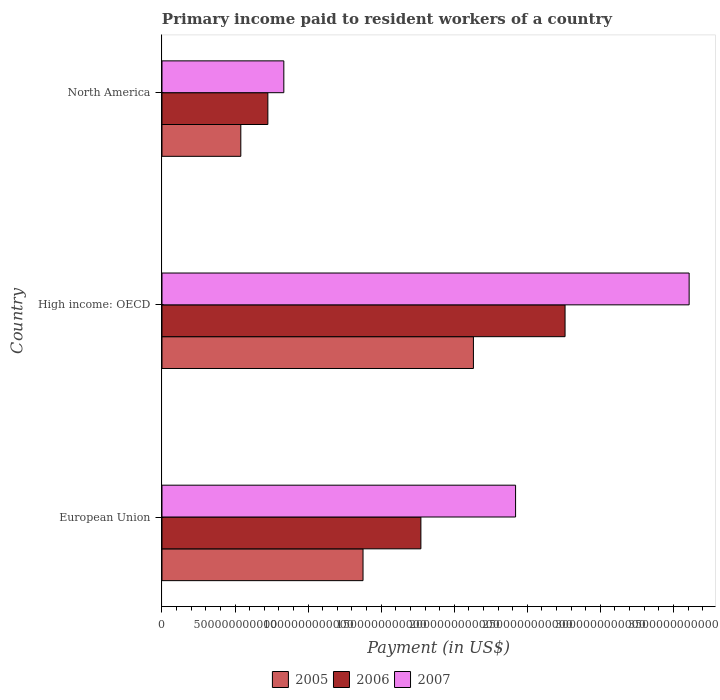How many different coloured bars are there?
Ensure brevity in your answer.  3. How many groups of bars are there?
Provide a succinct answer. 3. How many bars are there on the 3rd tick from the bottom?
Provide a short and direct response. 3. What is the label of the 2nd group of bars from the top?
Keep it short and to the point. High income: OECD. In how many cases, is the number of bars for a given country not equal to the number of legend labels?
Keep it short and to the point. 0. What is the amount paid to workers in 2006 in North America?
Make the answer very short. 7.24e+11. Across all countries, what is the maximum amount paid to workers in 2005?
Offer a very short reply. 2.13e+12. Across all countries, what is the minimum amount paid to workers in 2005?
Offer a very short reply. 5.39e+11. In which country was the amount paid to workers in 2005 maximum?
Your answer should be very brief. High income: OECD. What is the total amount paid to workers in 2007 in the graph?
Provide a succinct answer. 6.86e+12. What is the difference between the amount paid to workers in 2007 in European Union and that in North America?
Ensure brevity in your answer.  1.59e+12. What is the difference between the amount paid to workers in 2007 in High income: OECD and the amount paid to workers in 2006 in European Union?
Give a very brief answer. 1.84e+12. What is the average amount paid to workers in 2006 per country?
Your answer should be very brief. 1.75e+12. What is the difference between the amount paid to workers in 2006 and amount paid to workers in 2007 in High income: OECD?
Offer a very short reply. -8.49e+11. What is the ratio of the amount paid to workers in 2005 in European Union to that in High income: OECD?
Ensure brevity in your answer.  0.65. Is the difference between the amount paid to workers in 2006 in European Union and North America greater than the difference between the amount paid to workers in 2007 in European Union and North America?
Offer a terse response. No. What is the difference between the highest and the second highest amount paid to workers in 2006?
Offer a very short reply. 9.87e+11. What is the difference between the highest and the lowest amount paid to workers in 2006?
Your answer should be very brief. 2.03e+12. In how many countries, is the amount paid to workers in 2006 greater than the average amount paid to workers in 2006 taken over all countries?
Offer a terse response. 2. Is it the case that in every country, the sum of the amount paid to workers in 2007 and amount paid to workers in 2005 is greater than the amount paid to workers in 2006?
Your answer should be very brief. Yes. How many bars are there?
Give a very brief answer. 9. Are all the bars in the graph horizontal?
Your response must be concise. Yes. How many countries are there in the graph?
Give a very brief answer. 3. What is the difference between two consecutive major ticks on the X-axis?
Keep it short and to the point. 5.00e+11. How are the legend labels stacked?
Your response must be concise. Horizontal. What is the title of the graph?
Make the answer very short. Primary income paid to resident workers of a country. Does "1995" appear as one of the legend labels in the graph?
Offer a very short reply. No. What is the label or title of the X-axis?
Give a very brief answer. Payment (in US$). What is the Payment (in US$) in 2005 in European Union?
Your answer should be compact. 1.38e+12. What is the Payment (in US$) in 2006 in European Union?
Provide a succinct answer. 1.77e+12. What is the Payment (in US$) of 2007 in European Union?
Make the answer very short. 2.42e+12. What is the Payment (in US$) of 2005 in High income: OECD?
Give a very brief answer. 2.13e+12. What is the Payment (in US$) of 2006 in High income: OECD?
Keep it short and to the point. 2.76e+12. What is the Payment (in US$) in 2007 in High income: OECD?
Offer a very short reply. 3.61e+12. What is the Payment (in US$) of 2005 in North America?
Your answer should be very brief. 5.39e+11. What is the Payment (in US$) of 2006 in North America?
Give a very brief answer. 7.24e+11. What is the Payment (in US$) in 2007 in North America?
Ensure brevity in your answer.  8.34e+11. Across all countries, what is the maximum Payment (in US$) in 2005?
Your response must be concise. 2.13e+12. Across all countries, what is the maximum Payment (in US$) in 2006?
Make the answer very short. 2.76e+12. Across all countries, what is the maximum Payment (in US$) in 2007?
Your answer should be very brief. 3.61e+12. Across all countries, what is the minimum Payment (in US$) of 2005?
Offer a terse response. 5.39e+11. Across all countries, what is the minimum Payment (in US$) of 2006?
Make the answer very short. 7.24e+11. Across all countries, what is the minimum Payment (in US$) of 2007?
Your answer should be compact. 8.34e+11. What is the total Payment (in US$) in 2005 in the graph?
Offer a terse response. 4.05e+12. What is the total Payment (in US$) of 2006 in the graph?
Ensure brevity in your answer.  5.25e+12. What is the total Payment (in US$) in 2007 in the graph?
Ensure brevity in your answer.  6.86e+12. What is the difference between the Payment (in US$) of 2005 in European Union and that in High income: OECD?
Give a very brief answer. -7.55e+11. What is the difference between the Payment (in US$) of 2006 in European Union and that in High income: OECD?
Keep it short and to the point. -9.87e+11. What is the difference between the Payment (in US$) in 2007 in European Union and that in High income: OECD?
Give a very brief answer. -1.19e+12. What is the difference between the Payment (in US$) of 2005 in European Union and that in North America?
Provide a succinct answer. 8.36e+11. What is the difference between the Payment (in US$) in 2006 in European Union and that in North America?
Provide a succinct answer. 1.05e+12. What is the difference between the Payment (in US$) in 2007 in European Union and that in North America?
Offer a very short reply. 1.59e+12. What is the difference between the Payment (in US$) in 2005 in High income: OECD and that in North America?
Your answer should be compact. 1.59e+12. What is the difference between the Payment (in US$) of 2006 in High income: OECD and that in North America?
Give a very brief answer. 2.03e+12. What is the difference between the Payment (in US$) in 2007 in High income: OECD and that in North America?
Your answer should be compact. 2.77e+12. What is the difference between the Payment (in US$) in 2005 in European Union and the Payment (in US$) in 2006 in High income: OECD?
Keep it short and to the point. -1.38e+12. What is the difference between the Payment (in US$) of 2005 in European Union and the Payment (in US$) of 2007 in High income: OECD?
Your response must be concise. -2.23e+12. What is the difference between the Payment (in US$) in 2006 in European Union and the Payment (in US$) in 2007 in High income: OECD?
Give a very brief answer. -1.84e+12. What is the difference between the Payment (in US$) in 2005 in European Union and the Payment (in US$) in 2006 in North America?
Keep it short and to the point. 6.51e+11. What is the difference between the Payment (in US$) in 2005 in European Union and the Payment (in US$) in 2007 in North America?
Give a very brief answer. 5.42e+11. What is the difference between the Payment (in US$) in 2006 in European Union and the Payment (in US$) in 2007 in North America?
Give a very brief answer. 9.38e+11. What is the difference between the Payment (in US$) in 2005 in High income: OECD and the Payment (in US$) in 2006 in North America?
Your answer should be very brief. 1.41e+12. What is the difference between the Payment (in US$) of 2005 in High income: OECD and the Payment (in US$) of 2007 in North America?
Your answer should be very brief. 1.30e+12. What is the difference between the Payment (in US$) in 2006 in High income: OECD and the Payment (in US$) in 2007 in North America?
Offer a terse response. 1.92e+12. What is the average Payment (in US$) in 2005 per country?
Make the answer very short. 1.35e+12. What is the average Payment (in US$) of 2006 per country?
Your answer should be very brief. 1.75e+12. What is the average Payment (in US$) in 2007 per country?
Provide a succinct answer. 2.29e+12. What is the difference between the Payment (in US$) in 2005 and Payment (in US$) in 2006 in European Union?
Provide a succinct answer. -3.96e+11. What is the difference between the Payment (in US$) in 2005 and Payment (in US$) in 2007 in European Union?
Your answer should be very brief. -1.04e+12. What is the difference between the Payment (in US$) of 2006 and Payment (in US$) of 2007 in European Union?
Offer a very short reply. -6.48e+11. What is the difference between the Payment (in US$) of 2005 and Payment (in US$) of 2006 in High income: OECD?
Provide a short and direct response. -6.27e+11. What is the difference between the Payment (in US$) in 2005 and Payment (in US$) in 2007 in High income: OECD?
Make the answer very short. -1.48e+12. What is the difference between the Payment (in US$) in 2006 and Payment (in US$) in 2007 in High income: OECD?
Provide a short and direct response. -8.49e+11. What is the difference between the Payment (in US$) of 2005 and Payment (in US$) of 2006 in North America?
Offer a terse response. -1.85e+11. What is the difference between the Payment (in US$) of 2005 and Payment (in US$) of 2007 in North America?
Provide a short and direct response. -2.94e+11. What is the difference between the Payment (in US$) in 2006 and Payment (in US$) in 2007 in North America?
Provide a succinct answer. -1.09e+11. What is the ratio of the Payment (in US$) in 2005 in European Union to that in High income: OECD?
Keep it short and to the point. 0.65. What is the ratio of the Payment (in US$) in 2006 in European Union to that in High income: OECD?
Provide a short and direct response. 0.64. What is the ratio of the Payment (in US$) of 2007 in European Union to that in High income: OECD?
Keep it short and to the point. 0.67. What is the ratio of the Payment (in US$) of 2005 in European Union to that in North America?
Your response must be concise. 2.55. What is the ratio of the Payment (in US$) of 2006 in European Union to that in North America?
Give a very brief answer. 2.45. What is the ratio of the Payment (in US$) in 2007 in European Union to that in North America?
Provide a succinct answer. 2.9. What is the ratio of the Payment (in US$) of 2005 in High income: OECD to that in North America?
Offer a terse response. 3.95. What is the ratio of the Payment (in US$) of 2006 in High income: OECD to that in North America?
Ensure brevity in your answer.  3.81. What is the ratio of the Payment (in US$) of 2007 in High income: OECD to that in North America?
Your answer should be compact. 4.33. What is the difference between the highest and the second highest Payment (in US$) of 2005?
Give a very brief answer. 7.55e+11. What is the difference between the highest and the second highest Payment (in US$) of 2006?
Your response must be concise. 9.87e+11. What is the difference between the highest and the second highest Payment (in US$) in 2007?
Provide a succinct answer. 1.19e+12. What is the difference between the highest and the lowest Payment (in US$) in 2005?
Provide a short and direct response. 1.59e+12. What is the difference between the highest and the lowest Payment (in US$) of 2006?
Your response must be concise. 2.03e+12. What is the difference between the highest and the lowest Payment (in US$) in 2007?
Give a very brief answer. 2.77e+12. 